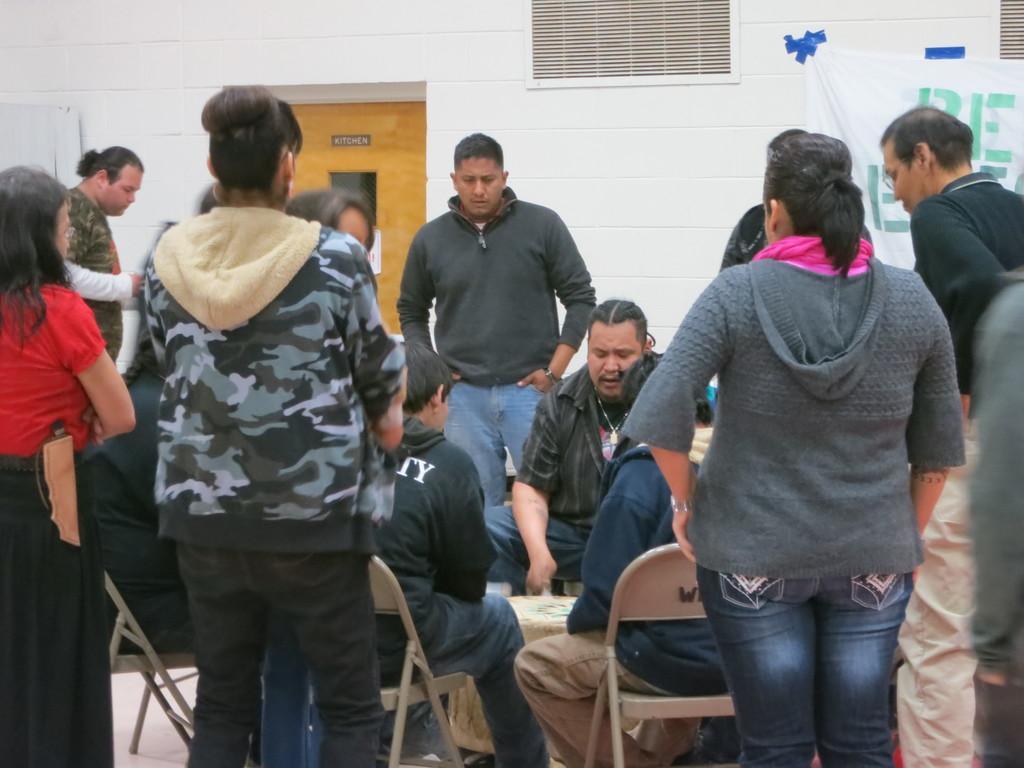Please provide a concise description of this image. In this picture I can see number of people in front and I see few of them are sitting and rest of them are standing. In the background I can see the wall and a white color cloth on the right side of this image and I see something is written. On the left side of this picture I can see a door. 